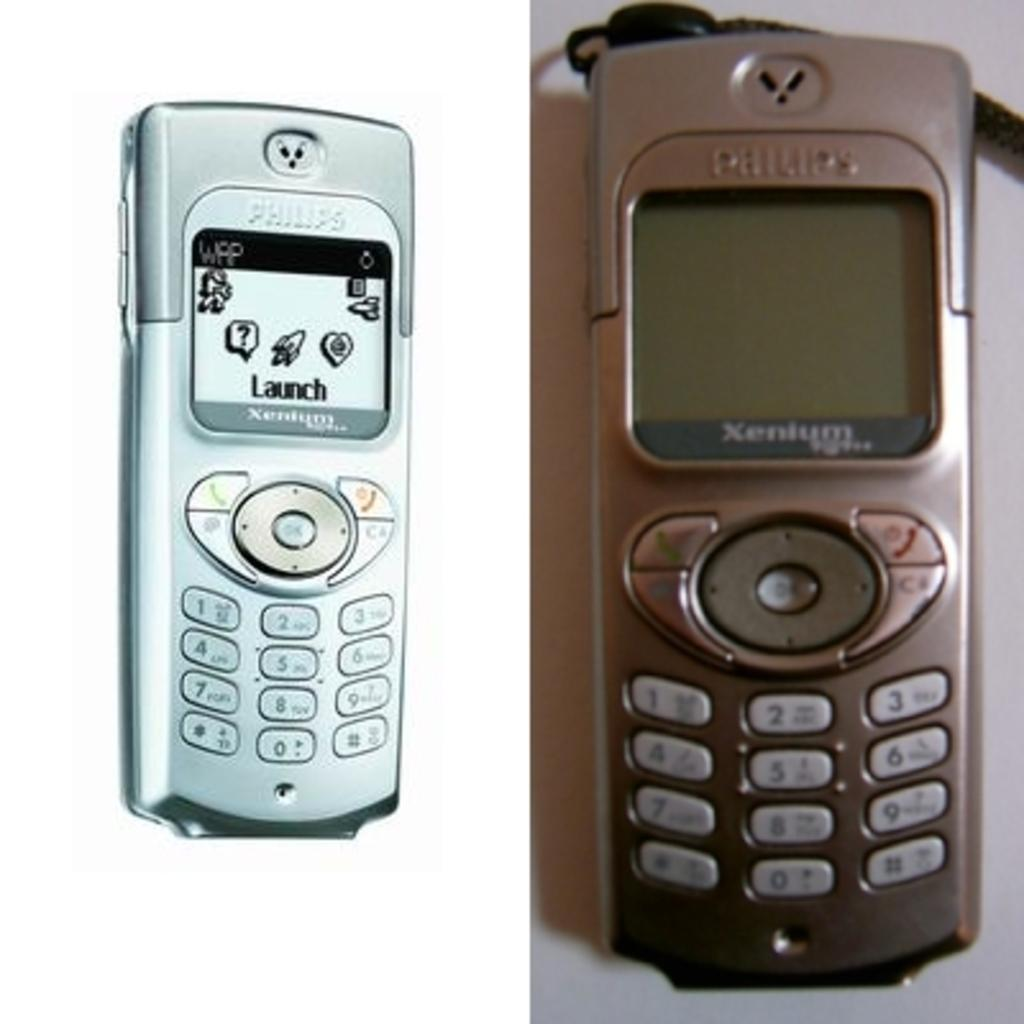Provide a one-sentence caption for the provided image. Two images of a Philips phone in different colors. 